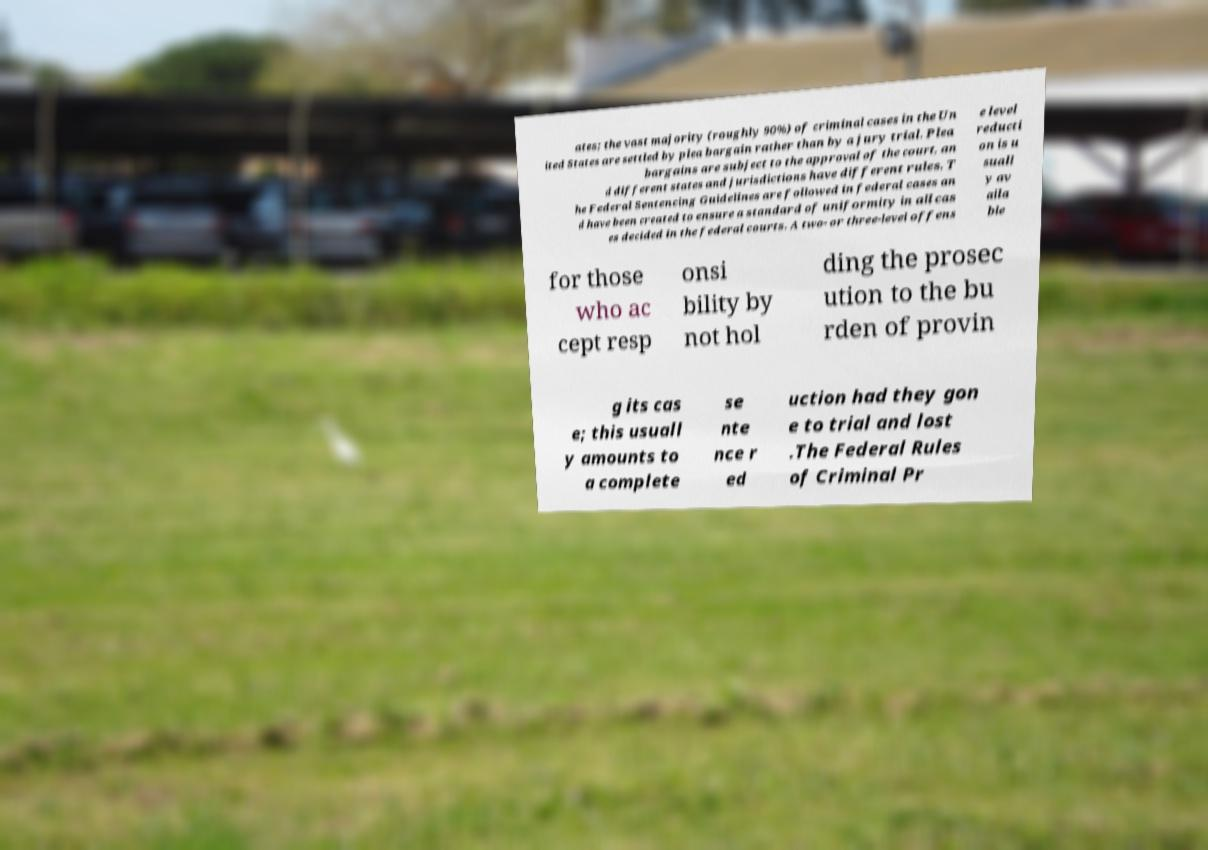Please read and relay the text visible in this image. What does it say? ates; the vast majority (roughly 90%) of criminal cases in the Un ited States are settled by plea bargain rather than by a jury trial. Plea bargains are subject to the approval of the court, an d different states and jurisdictions have different rules. T he Federal Sentencing Guidelines are followed in federal cases an d have been created to ensure a standard of uniformity in all cas es decided in the federal courts. A two- or three-level offens e level reducti on is u suall y av aila ble for those who ac cept resp onsi bility by not hol ding the prosec ution to the bu rden of provin g its cas e; this usuall y amounts to a complete se nte nce r ed uction had they gon e to trial and lost .The Federal Rules of Criminal Pr 